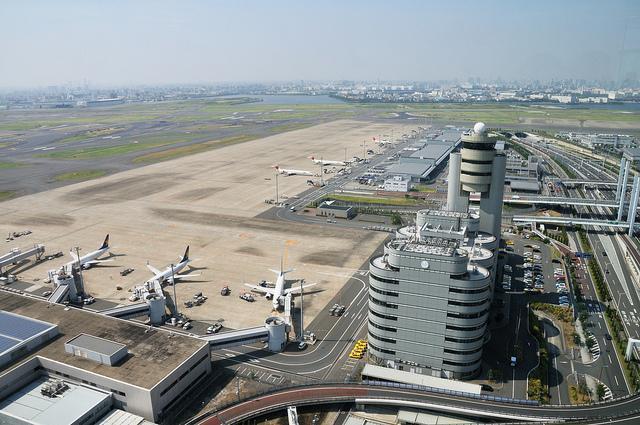How many people are wearing suspenders?
Give a very brief answer. 0. 